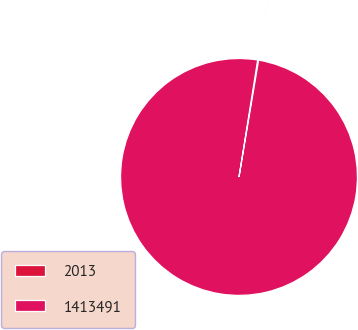Convert chart to OTSL. <chart><loc_0><loc_0><loc_500><loc_500><pie_chart><fcel>2013<fcel>1413491<nl><fcel>0.13%<fcel>99.87%<nl></chart> 